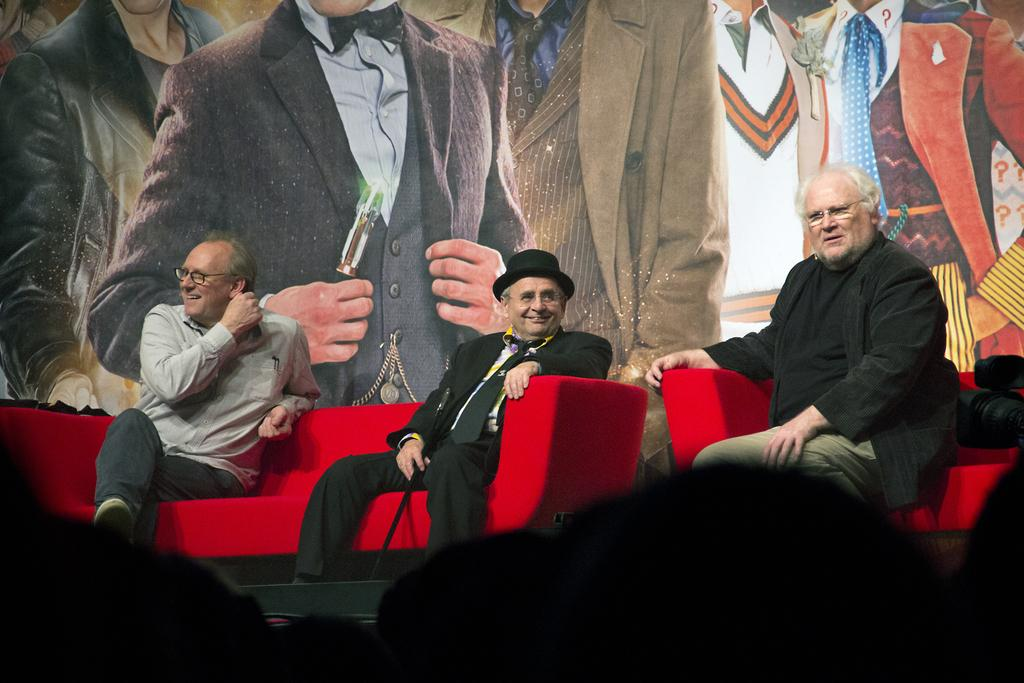What is the man sitting on in the image? The man is sitting on a red color sofa chair. What is the man wearing in the image? The man is wearing a black color dress and a hat. Is there any decoration visible in the image? Yes, there is a picture on the wall behind the man. What type of lumber is the man using to support the sofa chair in the image? There is no lumber visible in the image, and the sofa chair does not appear to need support. Who is the manager of the man in the image? The provided facts do not mention any manager or relationship between the man and others, so it cannot be determined from the image. 